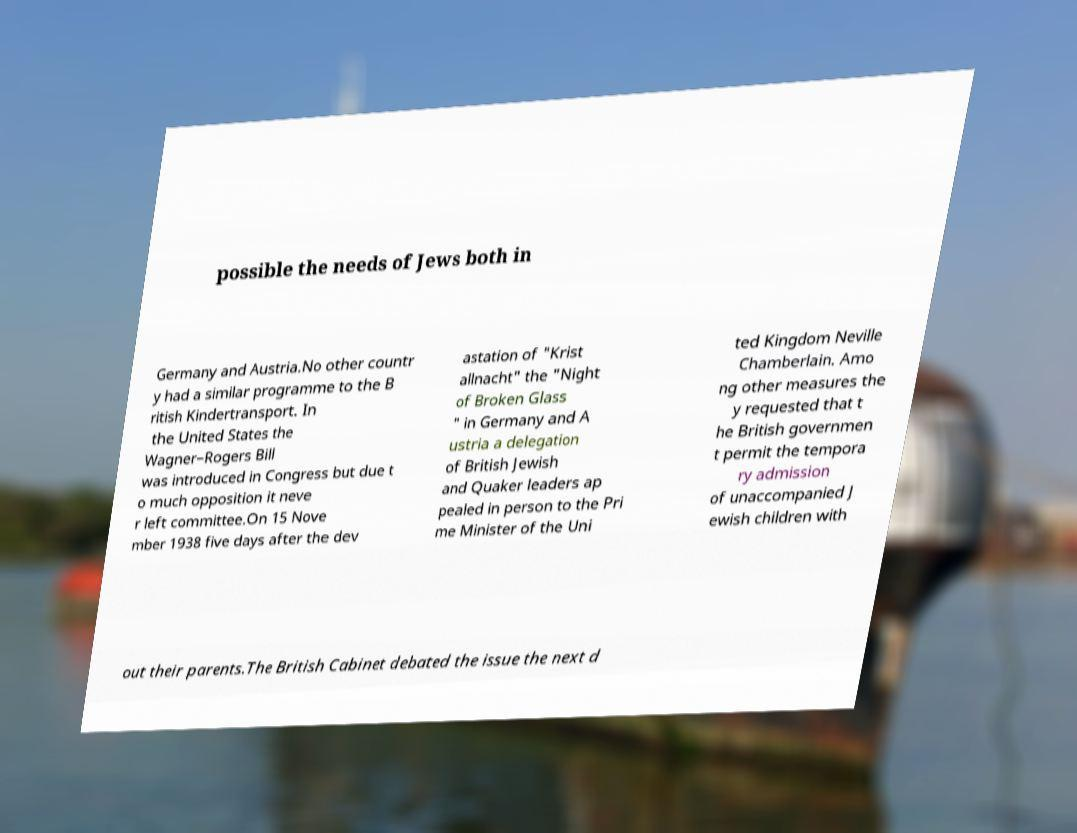Could you extract and type out the text from this image? possible the needs of Jews both in Germany and Austria.No other countr y had a similar programme to the B ritish Kindertransport. In the United States the Wagner–Rogers Bill was introduced in Congress but due t o much opposition it neve r left committee.On 15 Nove mber 1938 five days after the dev astation of "Krist allnacht" the "Night of Broken Glass " in Germany and A ustria a delegation of British Jewish and Quaker leaders ap pealed in person to the Pri me Minister of the Uni ted Kingdom Neville Chamberlain. Amo ng other measures the y requested that t he British governmen t permit the tempora ry admission of unaccompanied J ewish children with out their parents.The British Cabinet debated the issue the next d 